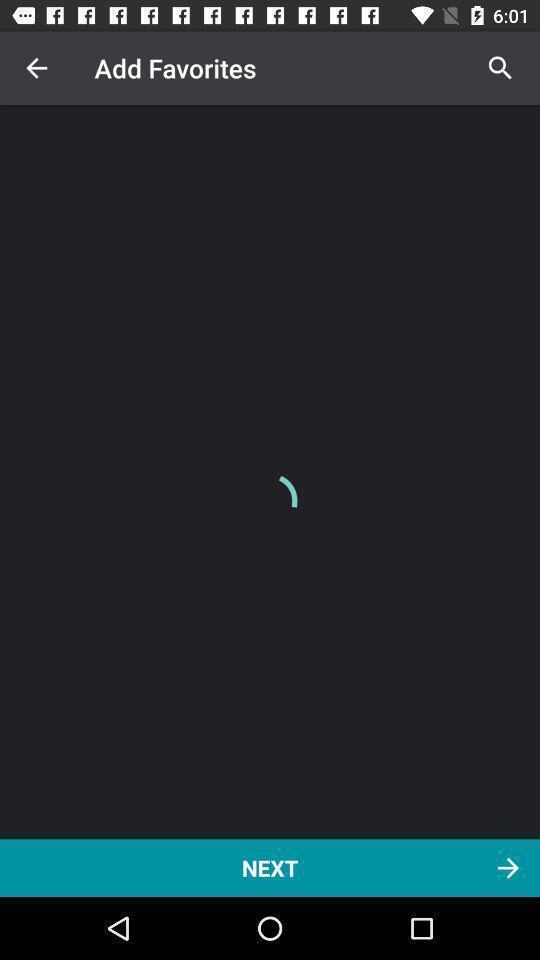Tell me about the visual elements in this screen capture. Page showing option like next. 